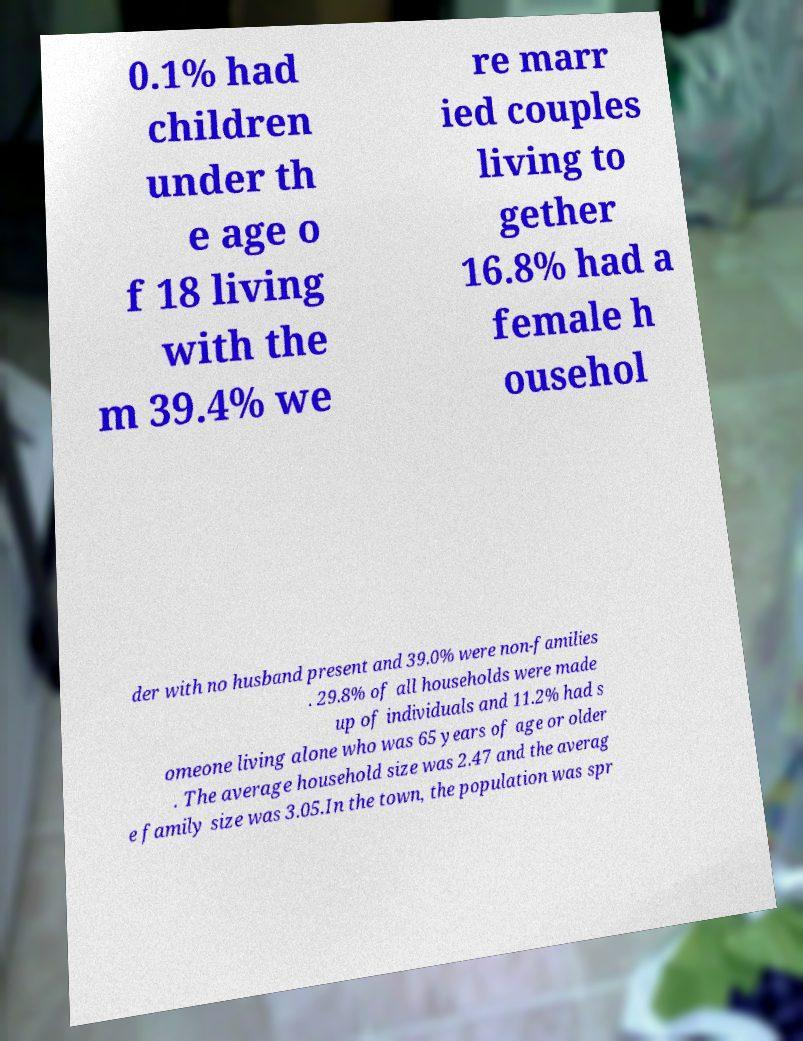Can you read and provide the text displayed in the image?This photo seems to have some interesting text. Can you extract and type it out for me? 0.1% had children under th e age o f 18 living with the m 39.4% we re marr ied couples living to gether 16.8% had a female h ousehol der with no husband present and 39.0% were non-families . 29.8% of all households were made up of individuals and 11.2% had s omeone living alone who was 65 years of age or older . The average household size was 2.47 and the averag e family size was 3.05.In the town, the population was spr 